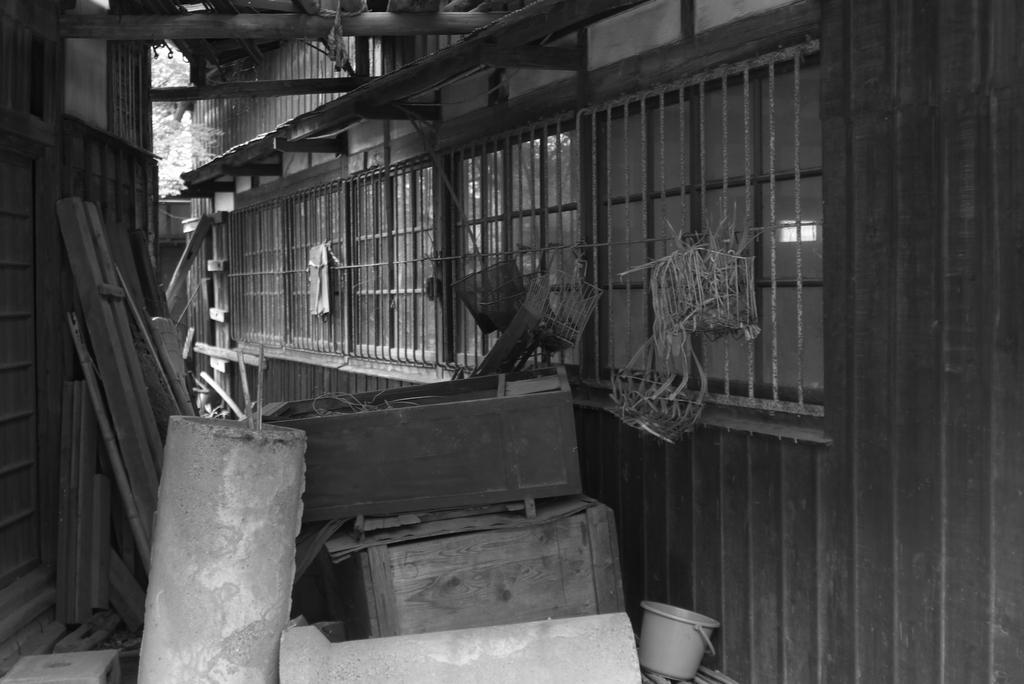What type of structure is visible in the image? There is a house in the image. What feature can be seen on the house? The house has windows. What object is present in the image that might be used for ventilation or security? There is a grille in the image. What type of material is used for some objects in the image? There are wooden objects in the image. What type of items can be seen in the image that might be used for storage? There are boxes in the image. What type of container is visible in the image? There is a bucket in the image. What type of natural elements can be seen in the image? There are trees in the image. How is the image presented in terms of color? The image is in black and white mode. What type of musical instrument is being played in harmony with the trees in the image? There is no musical instrument or harmony present in the image; it only features a house, windows, grille, wooden objects, boxes, a bucket, trees, and is in black and white mode. 